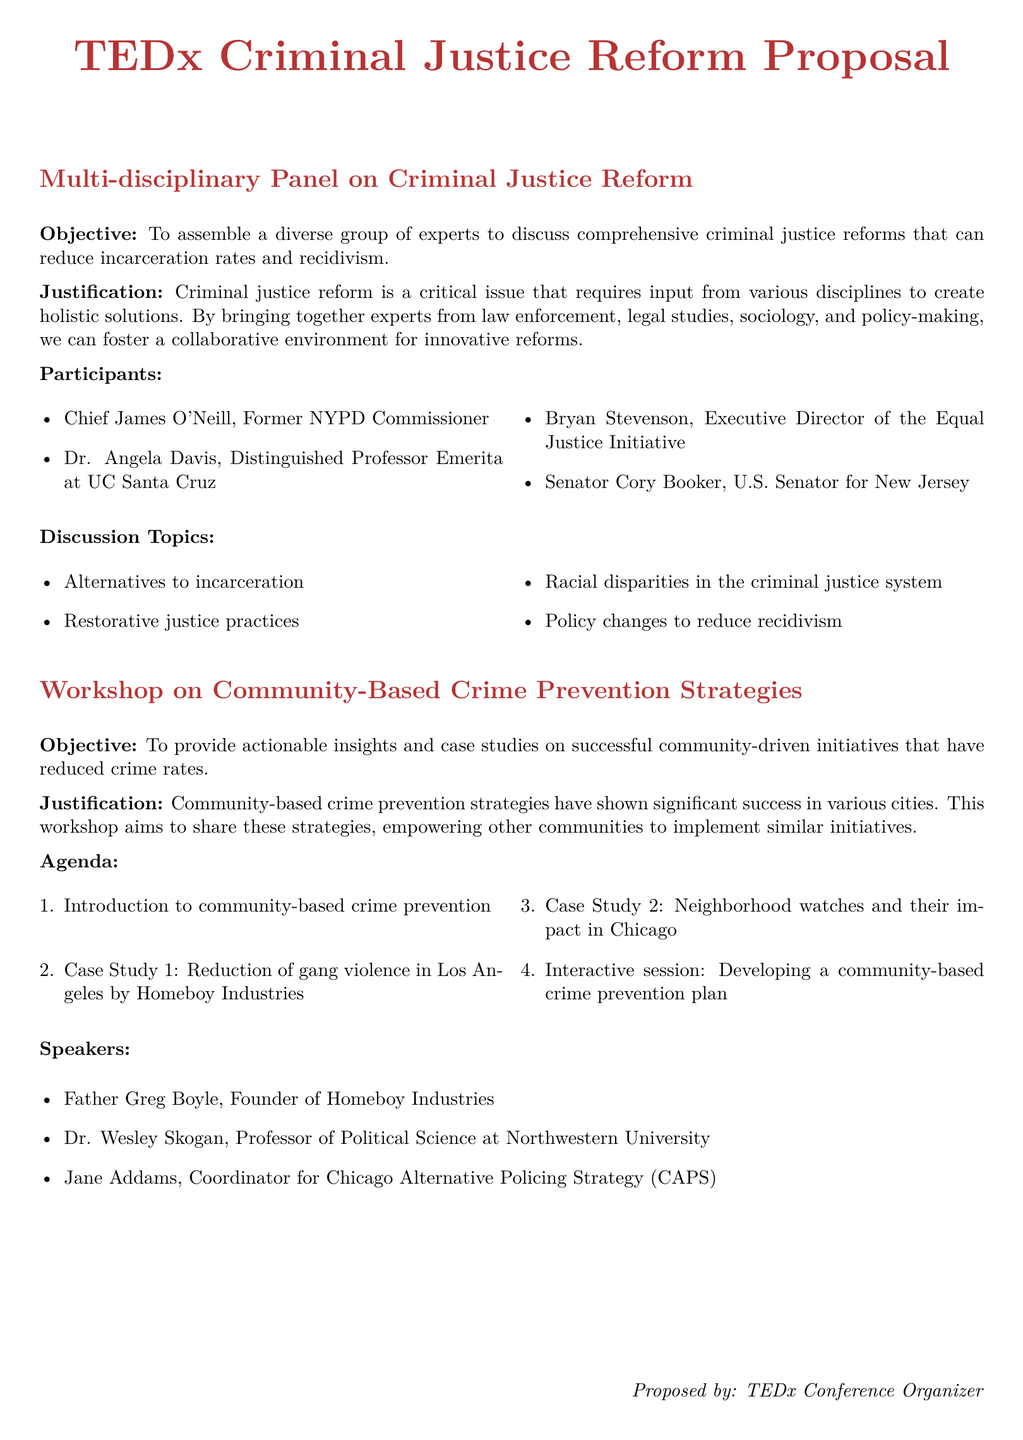What is the primary objective of the multi-disciplinary panel? The primary objective is to assemble a diverse group of experts to discuss comprehensive criminal justice reforms that can reduce incarceration rates and recidivism.
Answer: To assemble a diverse group of experts Who is one of the speakers at the workshop on community-based crime prevention strategies? One of the speakers is mentioned in the proposal for the workshop, and they are involved in community-based initiatives.
Answer: Father Greg Boyle What are two discussion topics in the multi-disciplinary panel? The proposal lists several discussion topics and two of them can be retrieved easily from the list provided in the document.
Answer: Alternatives to incarceration; Racial disparities in the criminal justice system What issue does the workshop aim to address? The workshop aims to provide insights into community-driven initiatives that have successfully reduced crime rates, which is an essential focus area in the proposal.
Answer: Community-driven initiatives How many case studies are included in the workshop agenda? The agenda outlines the structure and includes distinct case studies relevant to the workshop's theme, leading to a countable number of them.
Answer: 2 Which title does the workshop fall under in the proposal? The title of the workshop is specified directly in the document, making it straightforward to identify.
Answer: Workshop on Community-Based Crime Prevention Strategies How does the document suggest engaging workshop attendees? The proposal includes an interactive session as part of the workshop agenda, indicating a focus on engagement with attendees.
Answer: Interactive session What is the role of the proposed keynote speaker? The keynote speaker's potential impact is described in relation to the subject covered, outlining their background and journey post-rehabilitation.
Answer: Rehabilitation and Reintegration What is a key theme discussed in the proposed panel on cybercrime? The panel will address the broader implications of cybercrime on society, which is a major concern highlighted in the document.
Answer: Social implications of cybercrime 